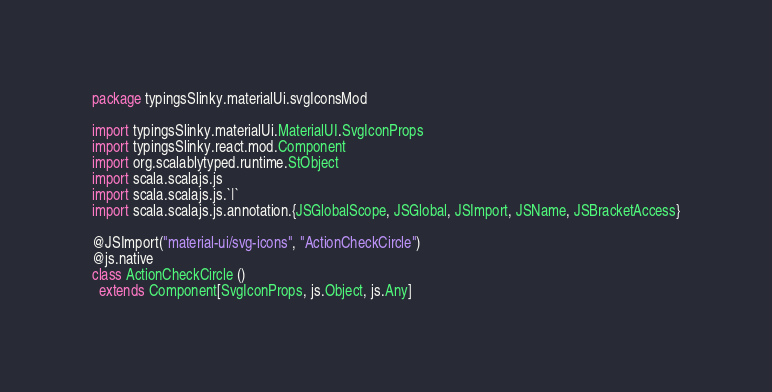Convert code to text. <code><loc_0><loc_0><loc_500><loc_500><_Scala_>package typingsSlinky.materialUi.svgIconsMod

import typingsSlinky.materialUi.MaterialUI.SvgIconProps
import typingsSlinky.react.mod.Component
import org.scalablytyped.runtime.StObject
import scala.scalajs.js
import scala.scalajs.js.`|`
import scala.scalajs.js.annotation.{JSGlobalScope, JSGlobal, JSImport, JSName, JSBracketAccess}

@JSImport("material-ui/svg-icons", "ActionCheckCircle")
@js.native
class ActionCheckCircle ()
  extends Component[SvgIconProps, js.Object, js.Any]
</code> 